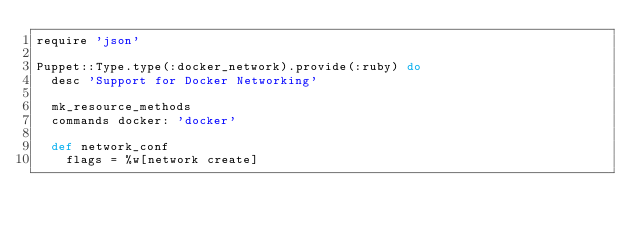<code> <loc_0><loc_0><loc_500><loc_500><_Ruby_>require 'json'

Puppet::Type.type(:docker_network).provide(:ruby) do
  desc 'Support for Docker Networking'

  mk_resource_methods
  commands docker: 'docker'

  def network_conf
    flags = %w[network create]</code> 